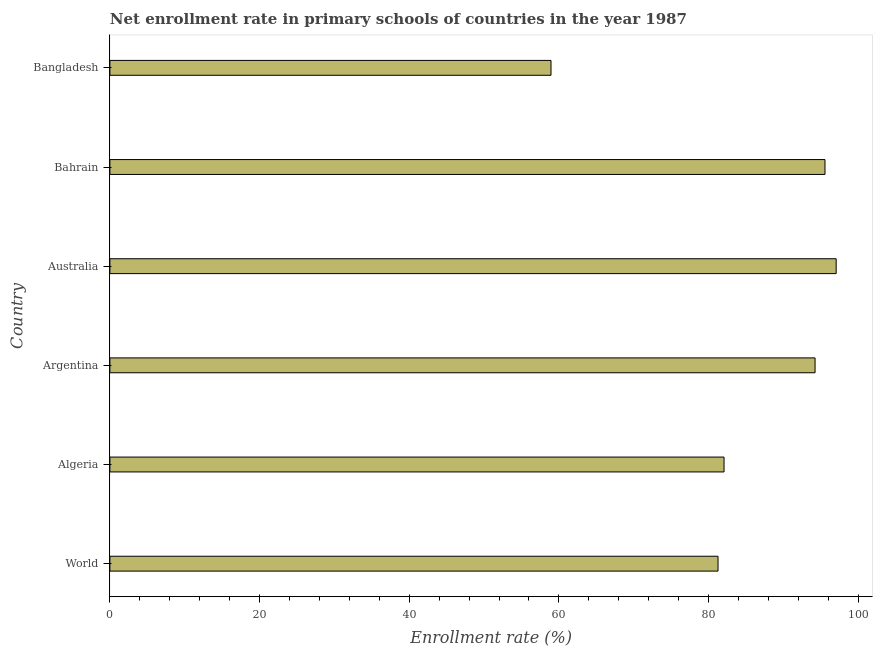Does the graph contain any zero values?
Ensure brevity in your answer.  No. Does the graph contain grids?
Provide a short and direct response. No. What is the title of the graph?
Offer a terse response. Net enrollment rate in primary schools of countries in the year 1987. What is the label or title of the X-axis?
Keep it short and to the point. Enrollment rate (%). What is the label or title of the Y-axis?
Provide a succinct answer. Country. What is the net enrollment rate in primary schools in Bangladesh?
Offer a very short reply. 58.95. Across all countries, what is the maximum net enrollment rate in primary schools?
Your answer should be compact. 97.05. Across all countries, what is the minimum net enrollment rate in primary schools?
Ensure brevity in your answer.  58.95. In which country was the net enrollment rate in primary schools maximum?
Give a very brief answer. Australia. In which country was the net enrollment rate in primary schools minimum?
Make the answer very short. Bangladesh. What is the sum of the net enrollment rate in primary schools?
Your answer should be compact. 509.12. What is the difference between the net enrollment rate in primary schools in Bangladesh and World?
Your answer should be compact. -22.32. What is the average net enrollment rate in primary schools per country?
Your answer should be compact. 84.85. What is the median net enrollment rate in primary schools?
Make the answer very short. 88.15. What is the ratio of the net enrollment rate in primary schools in Algeria to that in Bahrain?
Your answer should be very brief. 0.86. What is the difference between the highest and the second highest net enrollment rate in primary schools?
Your response must be concise. 1.5. Is the sum of the net enrollment rate in primary schools in Argentina and Bangladesh greater than the maximum net enrollment rate in primary schools across all countries?
Provide a succinct answer. Yes. What is the difference between the highest and the lowest net enrollment rate in primary schools?
Provide a short and direct response. 38.11. Are all the bars in the graph horizontal?
Ensure brevity in your answer.  Yes. How many countries are there in the graph?
Your answer should be very brief. 6. What is the Enrollment rate (%) of World?
Your answer should be compact. 81.27. What is the Enrollment rate (%) in Algeria?
Give a very brief answer. 82.07. What is the Enrollment rate (%) in Argentina?
Provide a short and direct response. 94.23. What is the Enrollment rate (%) of Australia?
Ensure brevity in your answer.  97.05. What is the Enrollment rate (%) in Bahrain?
Your answer should be very brief. 95.56. What is the Enrollment rate (%) in Bangladesh?
Offer a very short reply. 58.95. What is the difference between the Enrollment rate (%) in World and Algeria?
Make the answer very short. -0.8. What is the difference between the Enrollment rate (%) in World and Argentina?
Offer a terse response. -12.97. What is the difference between the Enrollment rate (%) in World and Australia?
Your answer should be compact. -15.79. What is the difference between the Enrollment rate (%) in World and Bahrain?
Your response must be concise. -14.29. What is the difference between the Enrollment rate (%) in World and Bangladesh?
Provide a succinct answer. 22.32. What is the difference between the Enrollment rate (%) in Algeria and Argentina?
Your answer should be very brief. -12.16. What is the difference between the Enrollment rate (%) in Algeria and Australia?
Ensure brevity in your answer.  -14.99. What is the difference between the Enrollment rate (%) in Algeria and Bahrain?
Offer a very short reply. -13.49. What is the difference between the Enrollment rate (%) in Algeria and Bangladesh?
Ensure brevity in your answer.  23.12. What is the difference between the Enrollment rate (%) in Argentina and Australia?
Keep it short and to the point. -2.82. What is the difference between the Enrollment rate (%) in Argentina and Bahrain?
Provide a short and direct response. -1.33. What is the difference between the Enrollment rate (%) in Argentina and Bangladesh?
Provide a succinct answer. 35.29. What is the difference between the Enrollment rate (%) in Australia and Bahrain?
Give a very brief answer. 1.5. What is the difference between the Enrollment rate (%) in Australia and Bangladesh?
Provide a short and direct response. 38.11. What is the difference between the Enrollment rate (%) in Bahrain and Bangladesh?
Your answer should be compact. 36.61. What is the ratio of the Enrollment rate (%) in World to that in Argentina?
Your answer should be compact. 0.86. What is the ratio of the Enrollment rate (%) in World to that in Australia?
Your response must be concise. 0.84. What is the ratio of the Enrollment rate (%) in World to that in Bahrain?
Keep it short and to the point. 0.85. What is the ratio of the Enrollment rate (%) in World to that in Bangladesh?
Give a very brief answer. 1.38. What is the ratio of the Enrollment rate (%) in Algeria to that in Argentina?
Provide a succinct answer. 0.87. What is the ratio of the Enrollment rate (%) in Algeria to that in Australia?
Offer a terse response. 0.85. What is the ratio of the Enrollment rate (%) in Algeria to that in Bahrain?
Offer a terse response. 0.86. What is the ratio of the Enrollment rate (%) in Algeria to that in Bangladesh?
Keep it short and to the point. 1.39. What is the ratio of the Enrollment rate (%) in Argentina to that in Australia?
Your answer should be compact. 0.97. What is the ratio of the Enrollment rate (%) in Argentina to that in Bangladesh?
Provide a short and direct response. 1.6. What is the ratio of the Enrollment rate (%) in Australia to that in Bangladesh?
Ensure brevity in your answer.  1.65. What is the ratio of the Enrollment rate (%) in Bahrain to that in Bangladesh?
Provide a short and direct response. 1.62. 